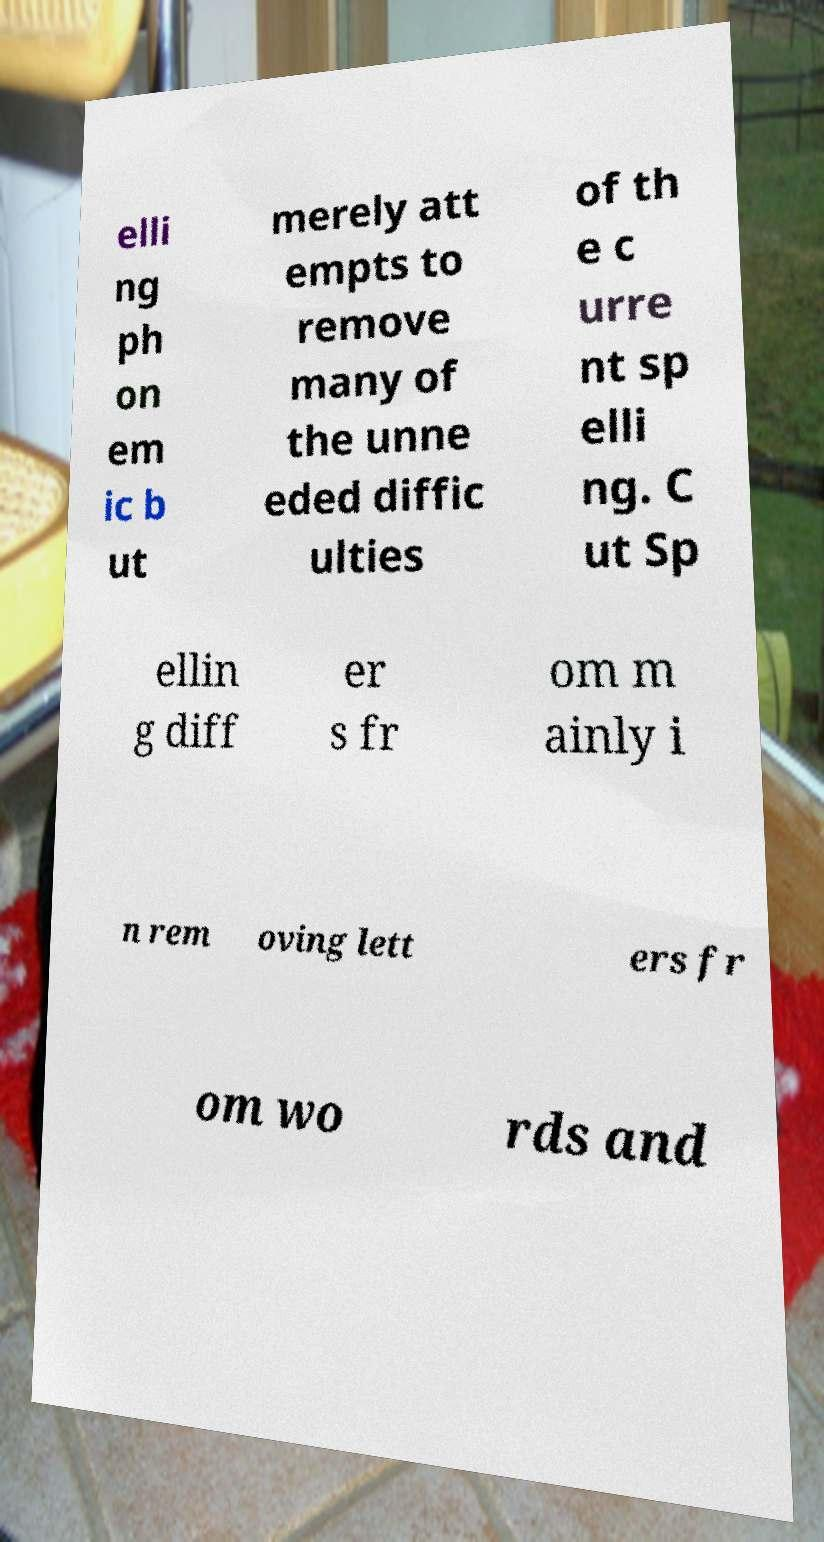For documentation purposes, I need the text within this image transcribed. Could you provide that? elli ng ph on em ic b ut merely att empts to remove many of the unne eded diffic ulties of th e c urre nt sp elli ng. C ut Sp ellin g diff er s fr om m ainly i n rem oving lett ers fr om wo rds and 